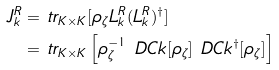<formula> <loc_0><loc_0><loc_500><loc_500>J ^ { R } _ { k } = & \ t r _ { K \times K } [ \rho _ { \zeta } L ^ { R } _ { k } ( L ^ { R } _ { k } ) ^ { \dag } ] \\ = & \ t r _ { K \times K } \left [ \rho _ { \zeta } ^ { - 1 } \ D C k [ \rho _ { \zeta } ] \ D C k ^ { \dag } [ \rho _ { \zeta } ] \right ]</formula> 